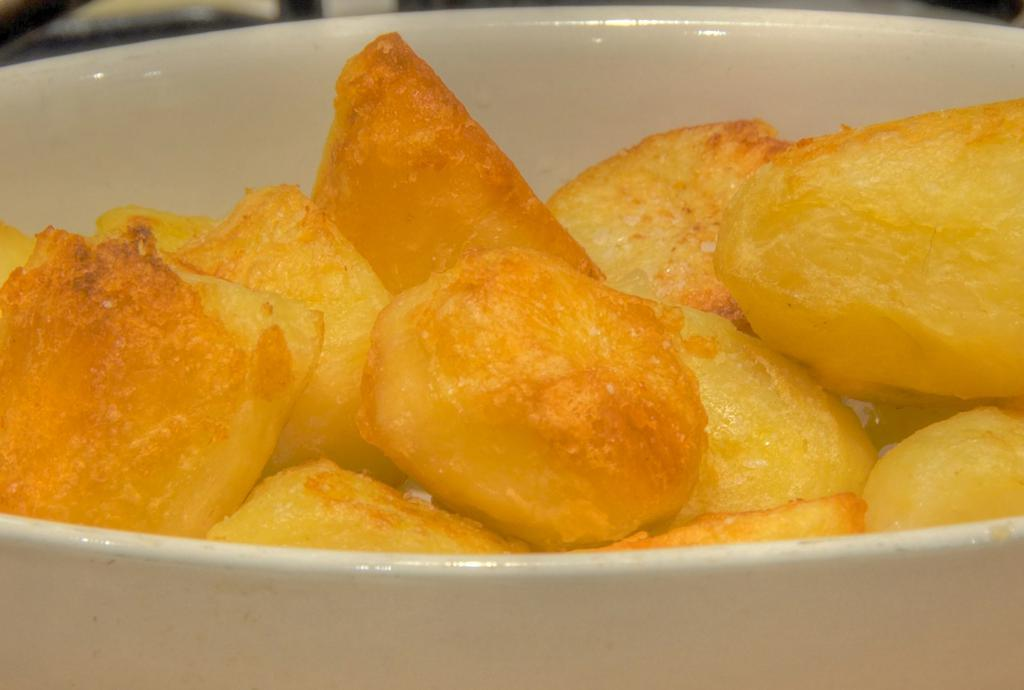What type of places are depicted in the image? There are food places in the image. How are the food places presented? The food places are in a white color bowl. What is the color of the food in the image? The food is in yellow color. How much tax is applied to the food in the image? There is no information about tax in the image, as it only shows food places and the color of the food. 